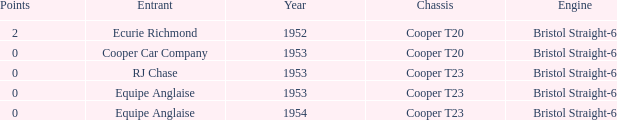Which entrant was present prior to 1953? Ecurie Richmond. 